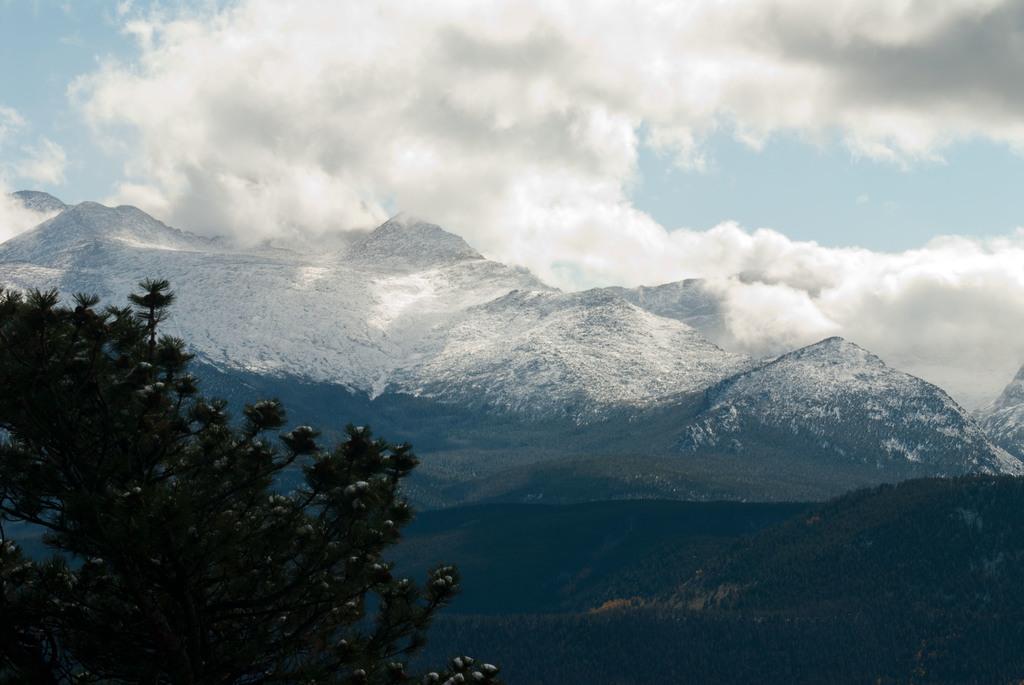Could you give a brief overview of what you see in this image? In the image we can see tree, mountain, cloudy sky and snow. 